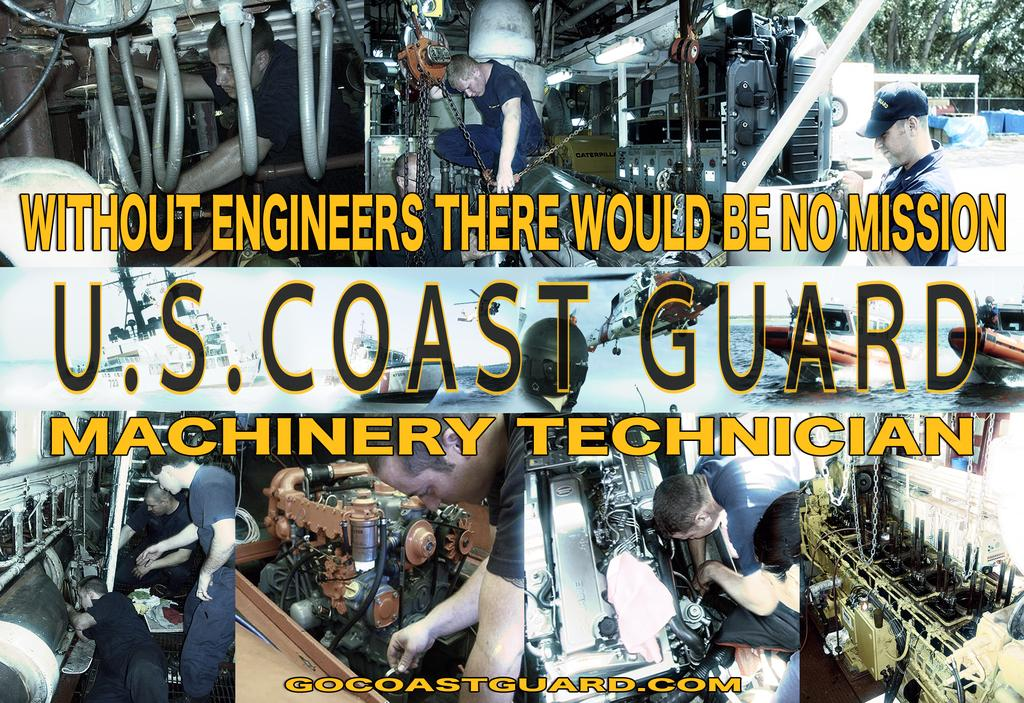What type of image is being described? The image is a collage. What can be seen in the collage? There are machines in the image. What are the people in the image doing? People are working with the machines. Is there any text present in the image? Yes, there is text present in the image. Can you see any elbows in the image? There is no mention of elbows in the provided facts, so we cannot determine if any are present in the image. Are there any planes visible in the image? There is no mention of planes in the provided facts, so we cannot determine if any are present in the image. 